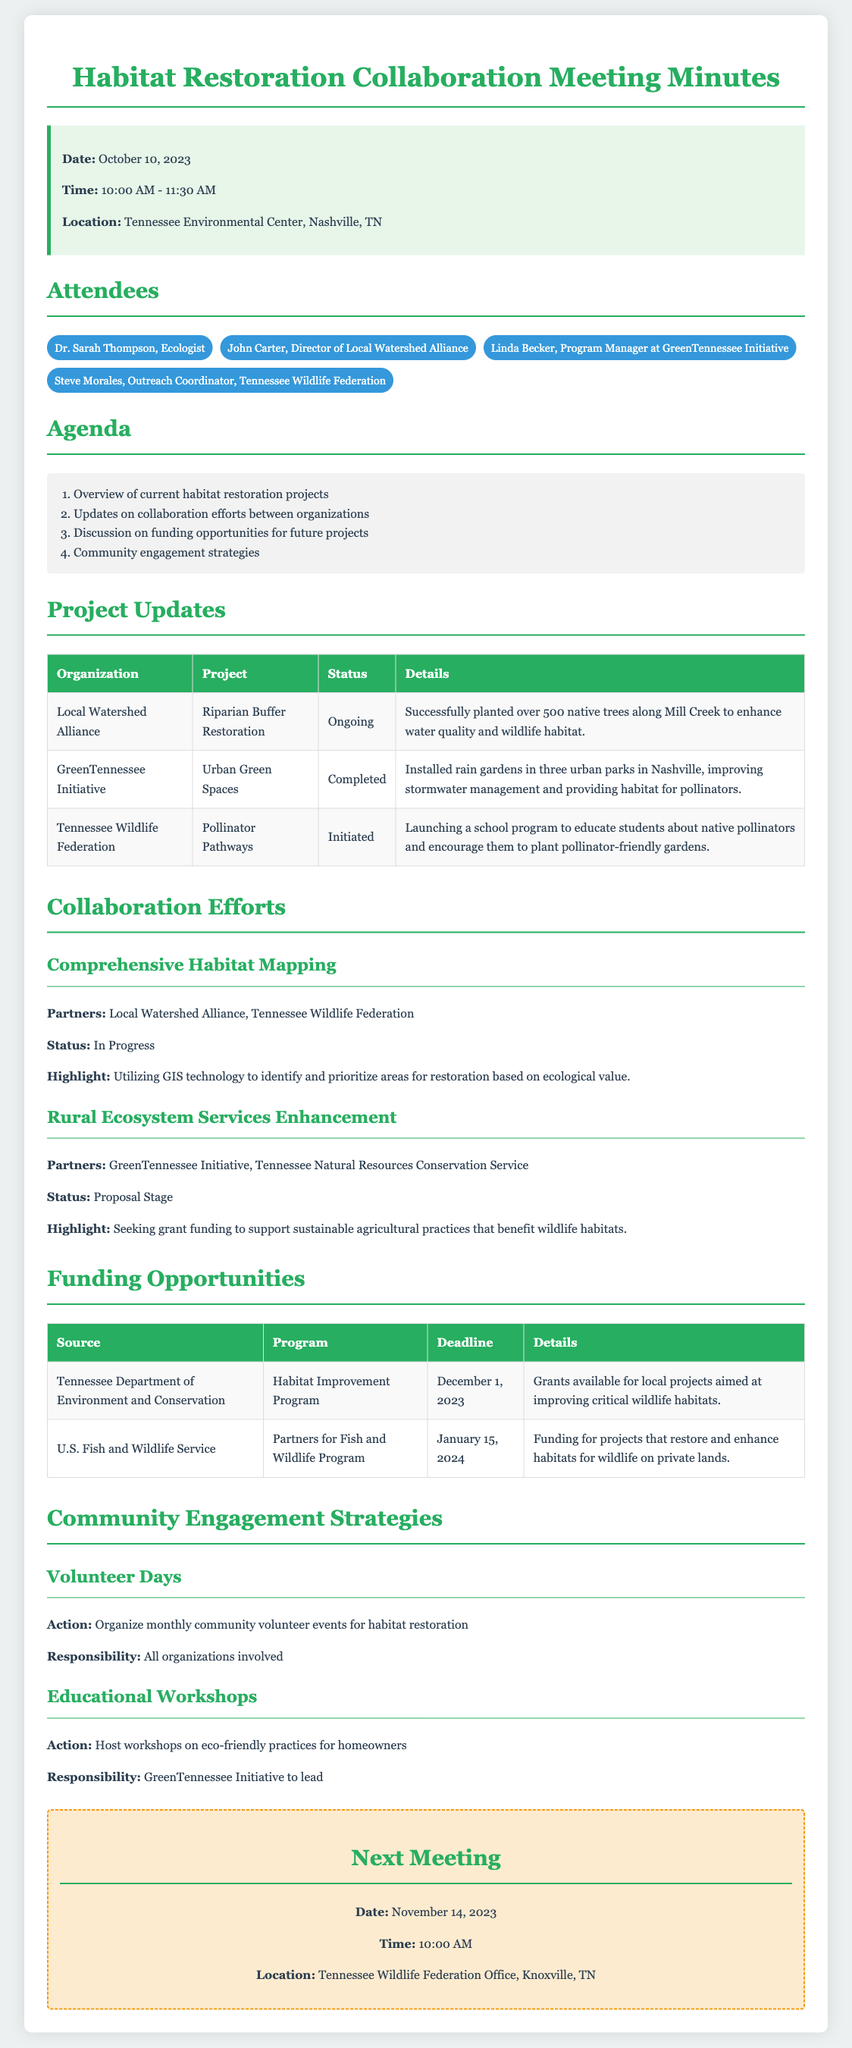What was the date of the meeting? The date is mentioned in the meeting info section.
Answer: October 10, 2023 Who is the Director of Local Watershed Alliance? This information can be found in the attendee list.
Answer: John Carter What is the status of the Riparian Buffer Restoration project? The status is provided in the project updates table.
Answer: Ongoing How many native trees were planted in the Mill Creek project? The number of trees planted is stated in the details of the project.
Answer: 500 What is the main highlight of the Comprehensive Habitat Mapping effort? The highlight is outlined in the collaboration efforts section.
Answer: Utilizing GIS technology What is the deadline for the Habitat Improvement Program funding? The deadline is included in the funding opportunities table.
Answer: December 1, 2023 What is the primary action for community engagement mentioned in the document? The actions for community engagement are stated in the strategies section.
Answer: Organize monthly community volunteer events Which organization is responsible for leading the educational workshops? The responsibility for the workshops is detailed in the community engagement strategies.
Answer: GreenTennessee Initiative What is the location of the next meeting? The location for the next meeting is provided at the end of the document.
Answer: Tennessee Wildlife Federation Office, Knoxville, TN 